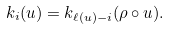<formula> <loc_0><loc_0><loc_500><loc_500>k _ { i } ( u ) = k _ { \ell ( u ) - i } ( \rho \circ u ) .</formula> 